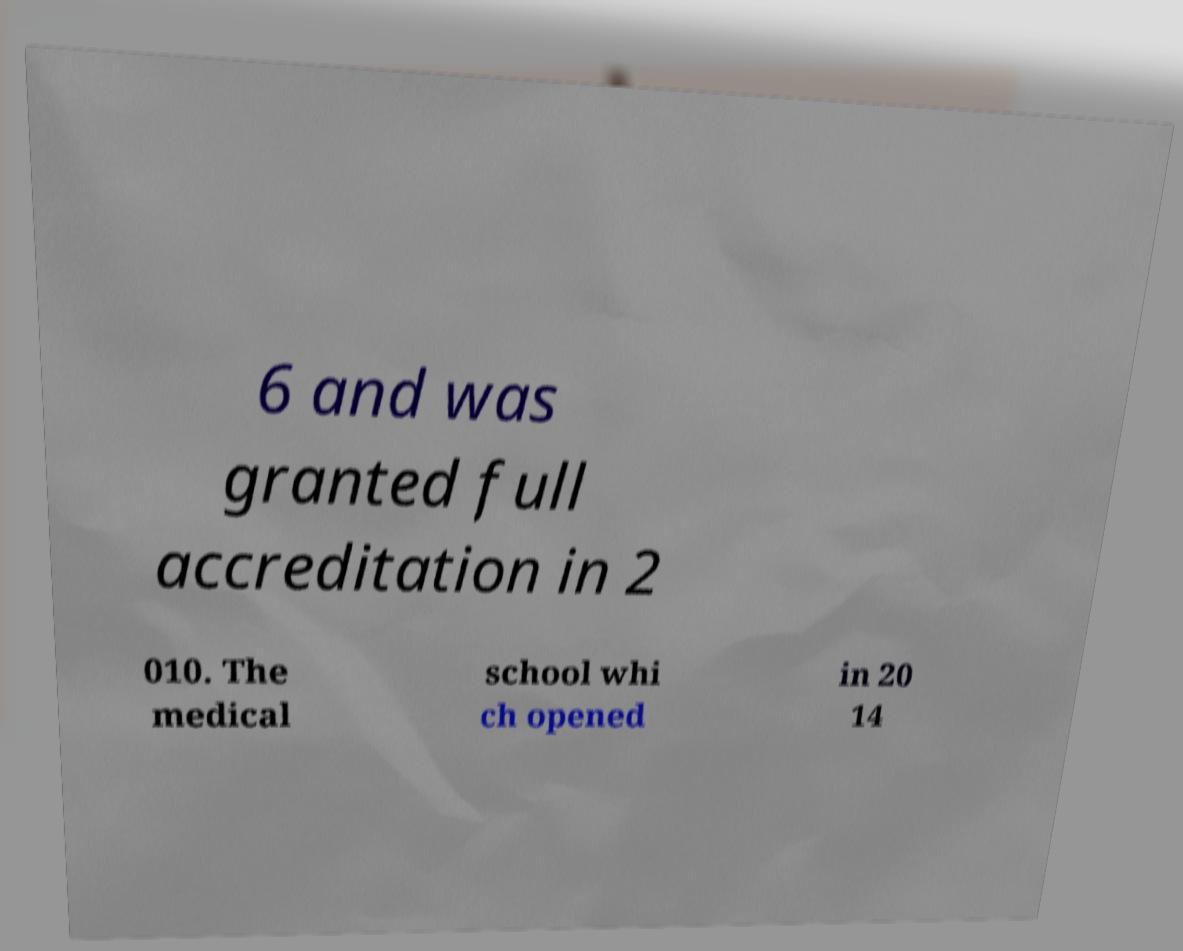Can you accurately transcribe the text from the provided image for me? 6 and was granted full accreditation in 2 010. The medical school whi ch opened in 20 14 